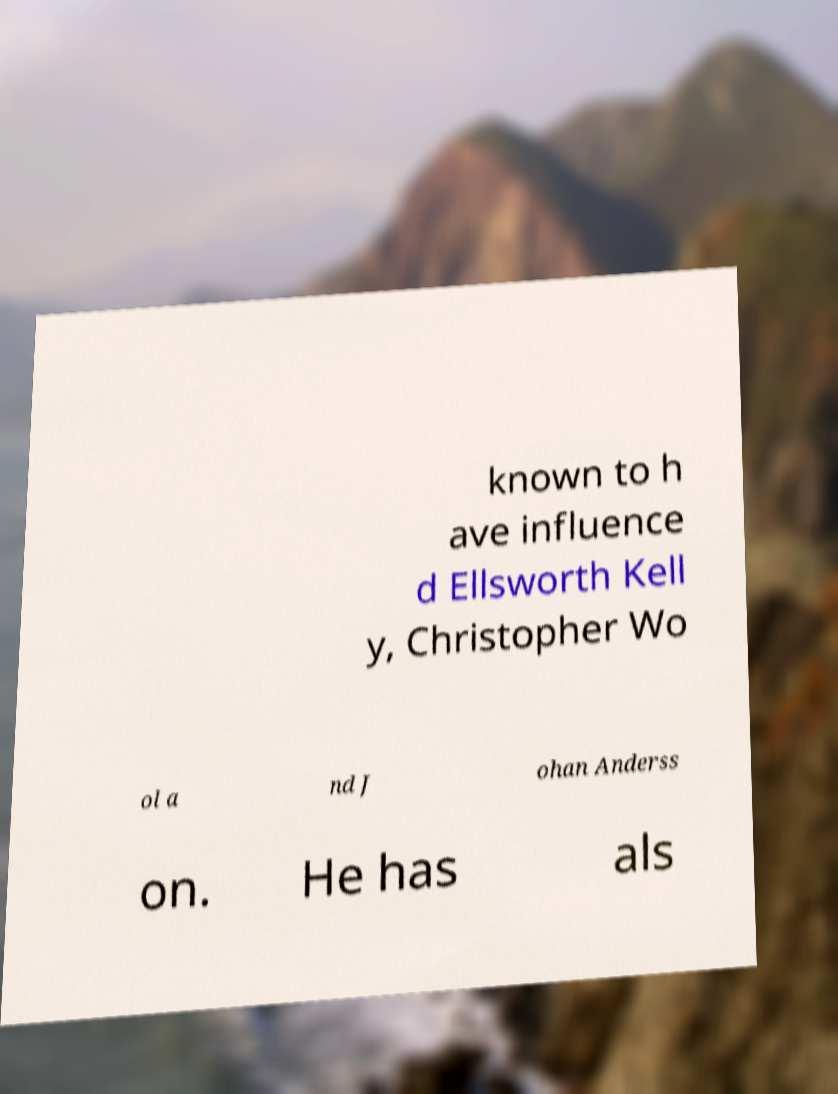Could you extract and type out the text from this image? known to h ave influence d Ellsworth Kell y, Christopher Wo ol a nd J ohan Anderss on. He has als 